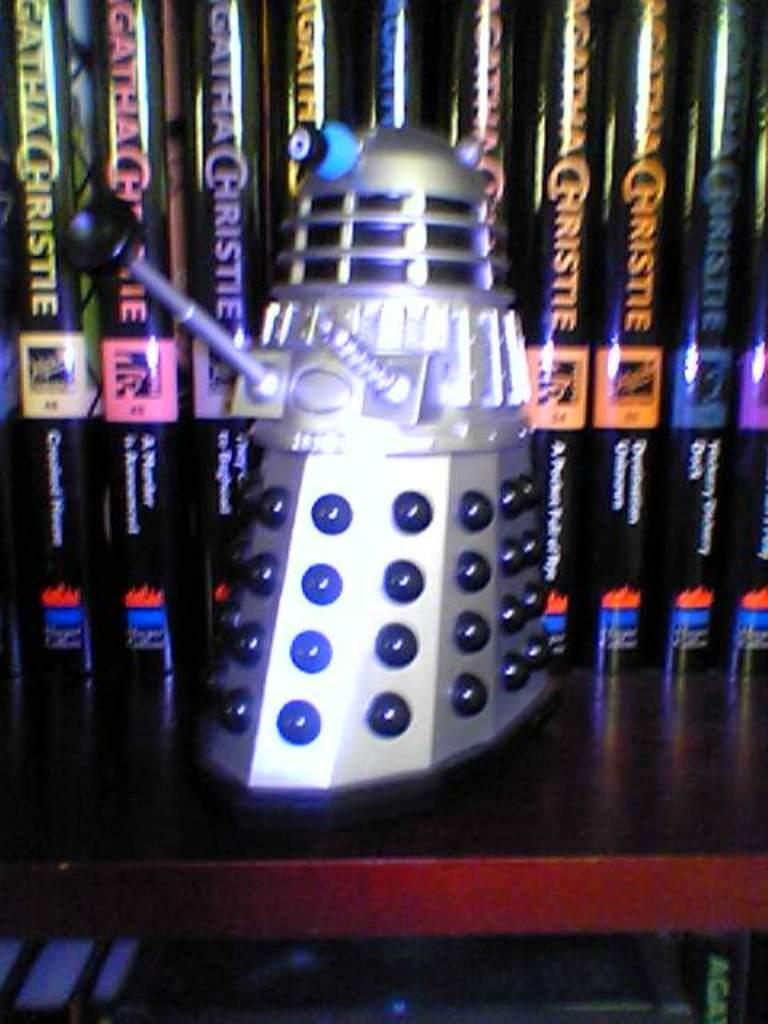<image>
Relay a brief, clear account of the picture shown. A dalek in front of a row of Agatha Christie novels. 